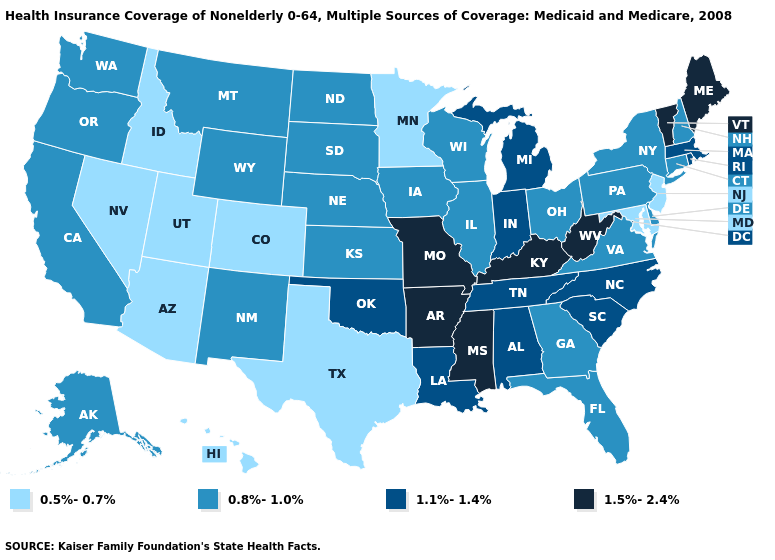What is the lowest value in the USA?
Be succinct. 0.5%-0.7%. What is the value of California?
Be succinct. 0.8%-1.0%. Among the states that border Wyoming , does Montana have the lowest value?
Concise answer only. No. Name the states that have a value in the range 0.8%-1.0%?
Answer briefly. Alaska, California, Connecticut, Delaware, Florida, Georgia, Illinois, Iowa, Kansas, Montana, Nebraska, New Hampshire, New Mexico, New York, North Dakota, Ohio, Oregon, Pennsylvania, South Dakota, Virginia, Washington, Wisconsin, Wyoming. What is the lowest value in states that border Colorado?
Keep it brief. 0.5%-0.7%. Among the states that border Illinois , does Wisconsin have the lowest value?
Write a very short answer. Yes. Name the states that have a value in the range 1.1%-1.4%?
Keep it brief. Alabama, Indiana, Louisiana, Massachusetts, Michigan, North Carolina, Oklahoma, Rhode Island, South Carolina, Tennessee. Which states have the lowest value in the West?
Answer briefly. Arizona, Colorado, Hawaii, Idaho, Nevada, Utah. Name the states that have a value in the range 1.5%-2.4%?
Quick response, please. Arkansas, Kentucky, Maine, Mississippi, Missouri, Vermont, West Virginia. Does Kentucky have the highest value in the USA?
Quick response, please. Yes. Name the states that have a value in the range 1.1%-1.4%?
Be succinct. Alabama, Indiana, Louisiana, Massachusetts, Michigan, North Carolina, Oklahoma, Rhode Island, South Carolina, Tennessee. What is the value of Hawaii?
Keep it brief. 0.5%-0.7%. What is the highest value in the Northeast ?
Answer briefly. 1.5%-2.4%. Name the states that have a value in the range 0.8%-1.0%?
Concise answer only. Alaska, California, Connecticut, Delaware, Florida, Georgia, Illinois, Iowa, Kansas, Montana, Nebraska, New Hampshire, New Mexico, New York, North Dakota, Ohio, Oregon, Pennsylvania, South Dakota, Virginia, Washington, Wisconsin, Wyoming. What is the lowest value in the USA?
Keep it brief. 0.5%-0.7%. 